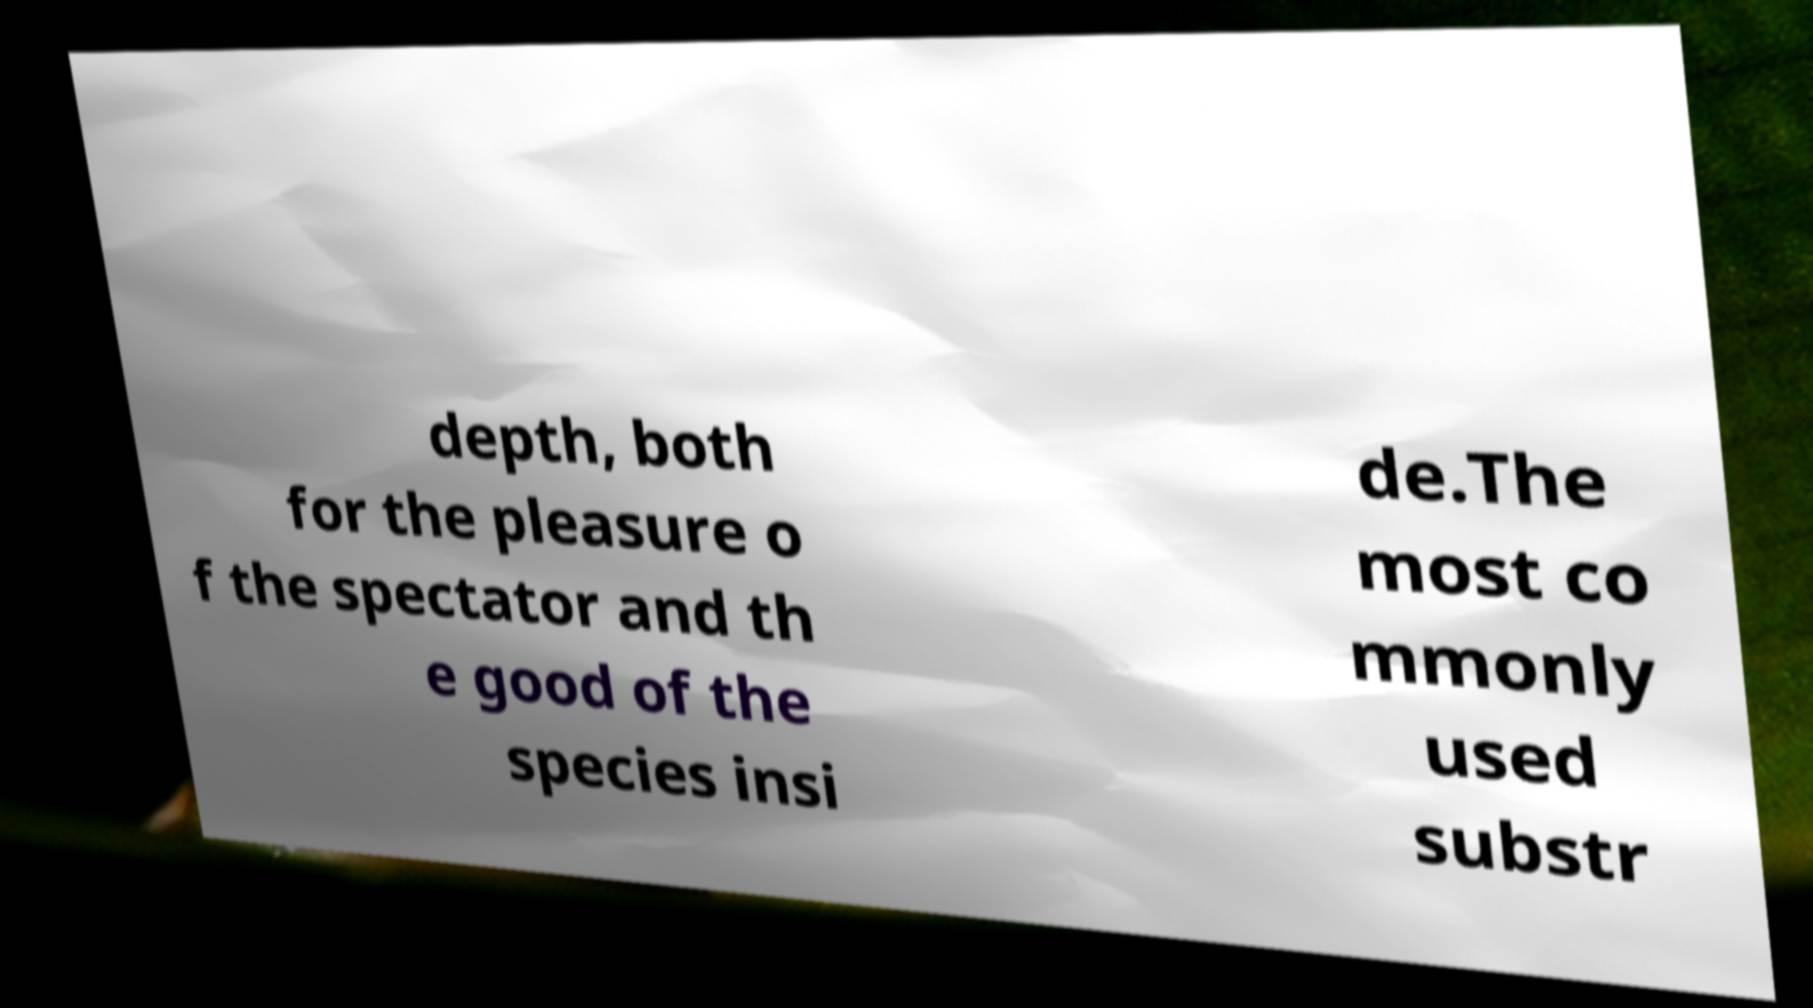Could you assist in decoding the text presented in this image and type it out clearly? depth, both for the pleasure o f the spectator and th e good of the species insi de.The most co mmonly used substr 